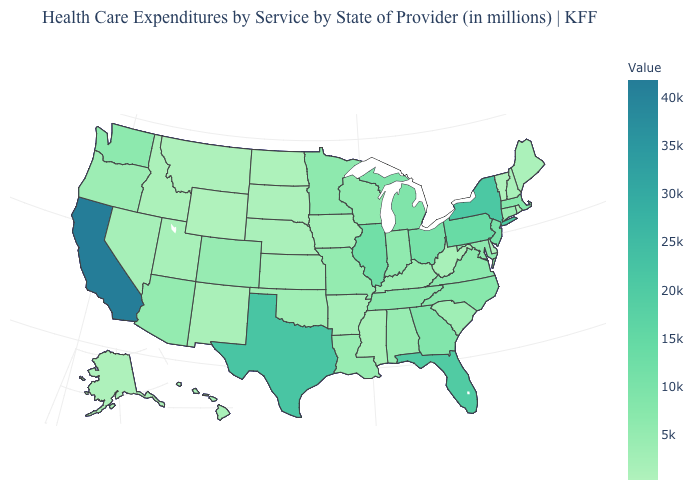Which states hav the highest value in the South?
Short answer required. Texas. Among the states that border Wisconsin , which have the highest value?
Be succinct. Illinois. Does New York have the highest value in the Northeast?
Keep it brief. Yes. Among the states that border North Dakota , does South Dakota have the highest value?
Be succinct. No. Among the states that border Delaware , which have the highest value?
Quick response, please. Pennsylvania. 